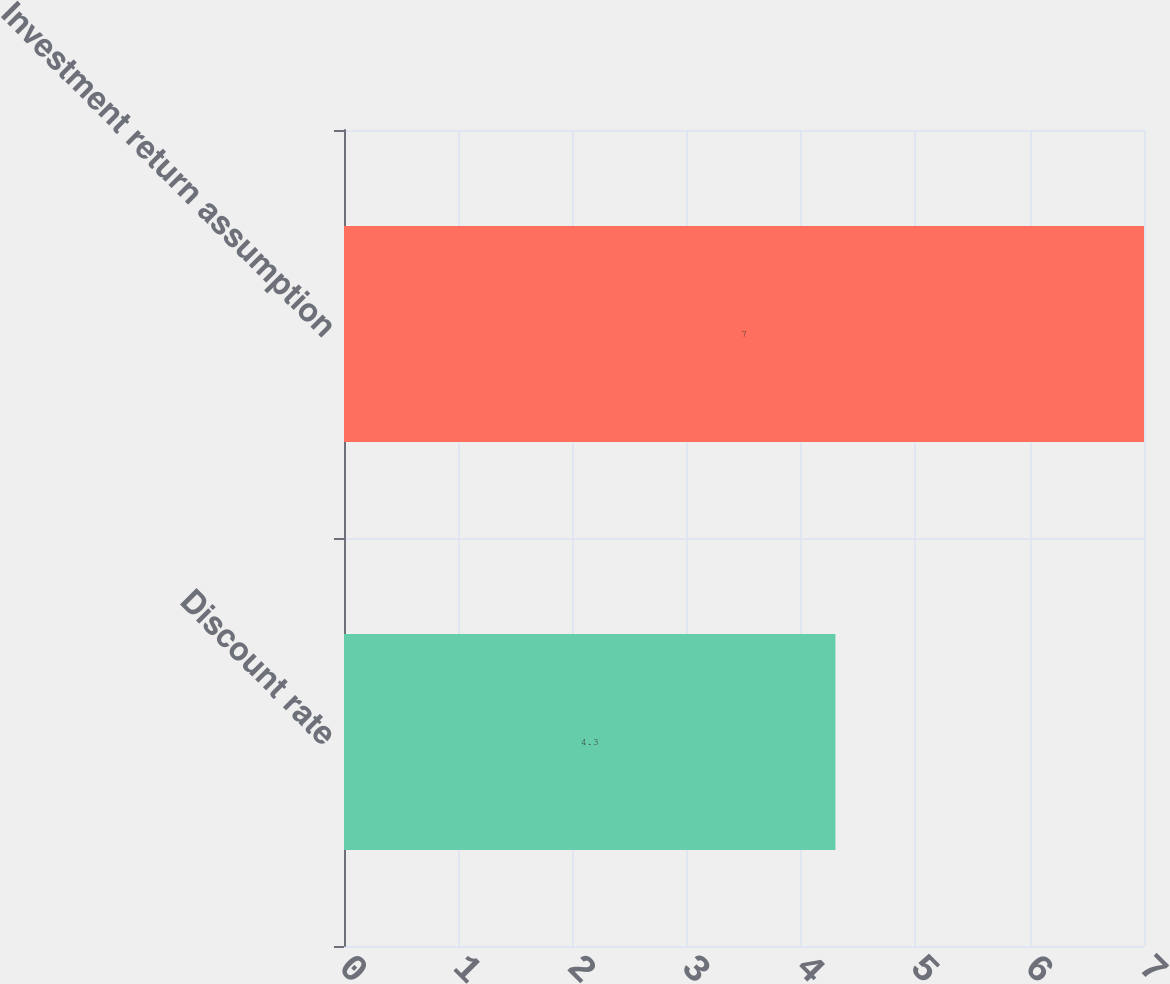Convert chart to OTSL. <chart><loc_0><loc_0><loc_500><loc_500><bar_chart><fcel>Discount rate<fcel>Investment return assumption<nl><fcel>4.3<fcel>7<nl></chart> 